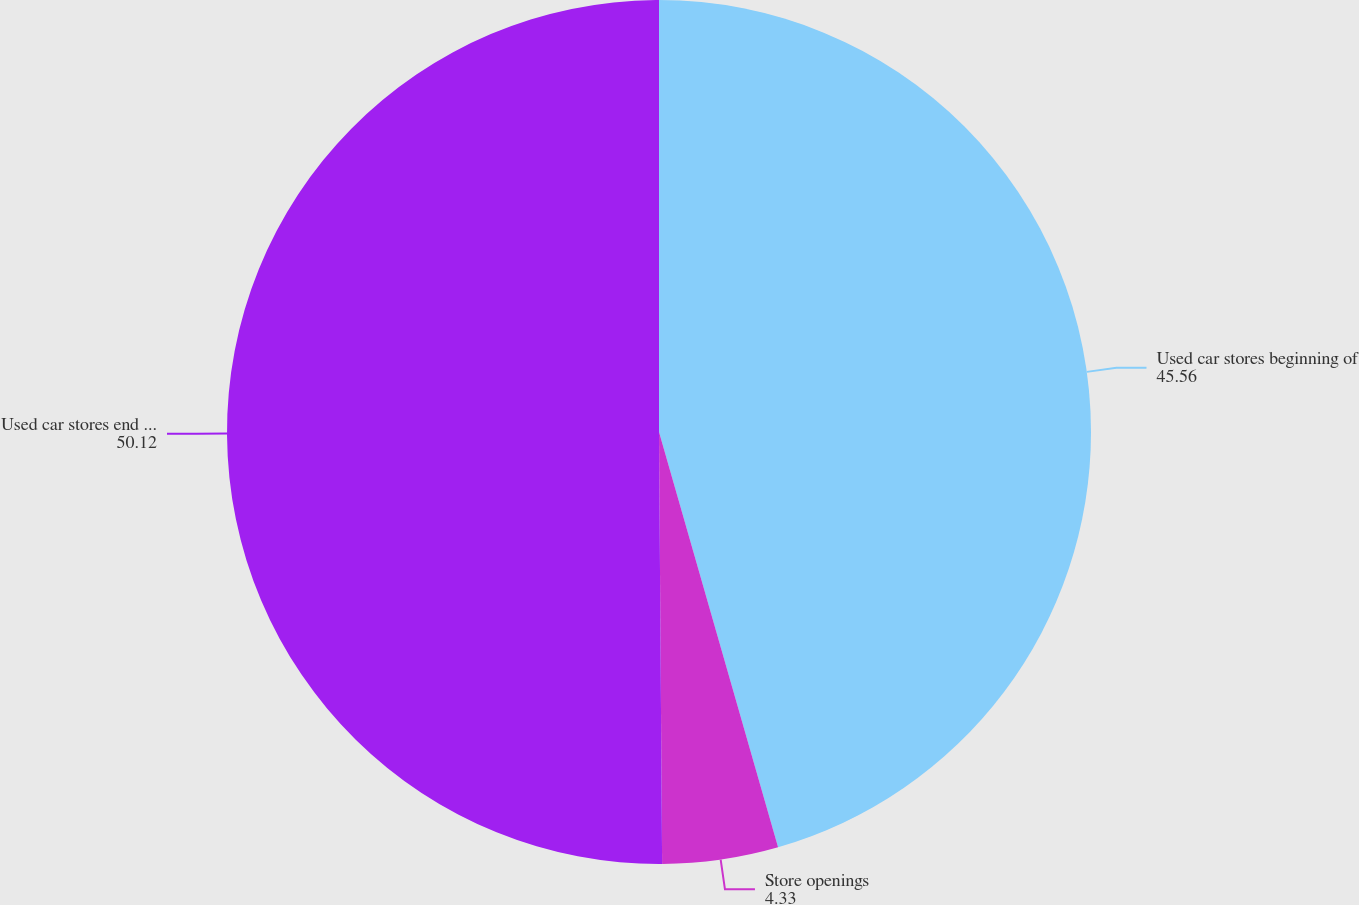<chart> <loc_0><loc_0><loc_500><loc_500><pie_chart><fcel>Used car stores beginning of<fcel>Store openings<fcel>Used car stores end of year<nl><fcel>45.56%<fcel>4.33%<fcel>50.12%<nl></chart> 